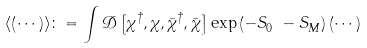<formula> <loc_0><loc_0><loc_500><loc_500>\langle \left ( \cdots \right ) \rangle \colon = \int \mathcal { D } \left [ \chi ^ { \dag } , \chi , \bar { \chi } ^ { \dag } , \bar { \chi } \right ] \exp \left ( - S ^ { \ } _ { 0 } - S ^ { \ } _ { M } \right ) \left ( \cdots \right )</formula> 